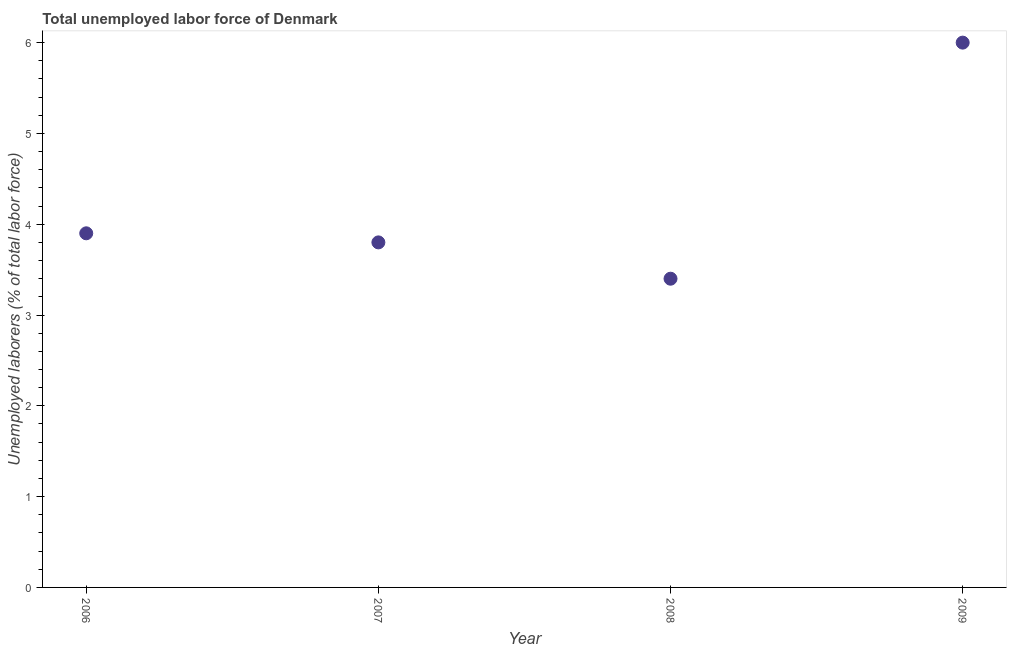What is the total unemployed labour force in 2007?
Provide a succinct answer. 3.8. Across all years, what is the minimum total unemployed labour force?
Provide a short and direct response. 3.4. In which year was the total unemployed labour force minimum?
Provide a short and direct response. 2008. What is the sum of the total unemployed labour force?
Your answer should be compact. 17.1. What is the difference between the total unemployed labour force in 2007 and 2009?
Give a very brief answer. -2.2. What is the average total unemployed labour force per year?
Offer a terse response. 4.28. What is the median total unemployed labour force?
Offer a very short reply. 3.85. In how many years, is the total unemployed labour force greater than 2.2 %?
Make the answer very short. 4. What is the ratio of the total unemployed labour force in 2007 to that in 2008?
Keep it short and to the point. 1.12. Is the difference between the total unemployed labour force in 2008 and 2009 greater than the difference between any two years?
Your answer should be very brief. Yes. What is the difference between the highest and the second highest total unemployed labour force?
Your answer should be very brief. 2.1. Is the sum of the total unemployed labour force in 2007 and 2008 greater than the maximum total unemployed labour force across all years?
Provide a short and direct response. Yes. What is the difference between the highest and the lowest total unemployed labour force?
Your response must be concise. 2.6. In how many years, is the total unemployed labour force greater than the average total unemployed labour force taken over all years?
Give a very brief answer. 1. How many dotlines are there?
Your response must be concise. 1. How many years are there in the graph?
Keep it short and to the point. 4. What is the difference between two consecutive major ticks on the Y-axis?
Provide a short and direct response. 1. Are the values on the major ticks of Y-axis written in scientific E-notation?
Ensure brevity in your answer.  No. Does the graph contain grids?
Make the answer very short. No. What is the title of the graph?
Keep it short and to the point. Total unemployed labor force of Denmark. What is the label or title of the Y-axis?
Keep it short and to the point. Unemployed laborers (% of total labor force). What is the Unemployed laborers (% of total labor force) in 2006?
Your answer should be compact. 3.9. What is the Unemployed laborers (% of total labor force) in 2007?
Your answer should be compact. 3.8. What is the Unemployed laborers (% of total labor force) in 2008?
Your response must be concise. 3.4. What is the Unemployed laborers (% of total labor force) in 2009?
Keep it short and to the point. 6. What is the difference between the Unemployed laborers (% of total labor force) in 2006 and 2007?
Give a very brief answer. 0.1. What is the difference between the Unemployed laborers (% of total labor force) in 2006 and 2008?
Keep it short and to the point. 0.5. What is the difference between the Unemployed laborers (% of total labor force) in 2006 and 2009?
Offer a very short reply. -2.1. What is the difference between the Unemployed laborers (% of total labor force) in 2007 and 2008?
Give a very brief answer. 0.4. What is the ratio of the Unemployed laborers (% of total labor force) in 2006 to that in 2007?
Your answer should be very brief. 1.03. What is the ratio of the Unemployed laborers (% of total labor force) in 2006 to that in 2008?
Your answer should be compact. 1.15. What is the ratio of the Unemployed laborers (% of total labor force) in 2006 to that in 2009?
Provide a short and direct response. 0.65. What is the ratio of the Unemployed laborers (% of total labor force) in 2007 to that in 2008?
Your answer should be compact. 1.12. What is the ratio of the Unemployed laborers (% of total labor force) in 2007 to that in 2009?
Make the answer very short. 0.63. What is the ratio of the Unemployed laborers (% of total labor force) in 2008 to that in 2009?
Give a very brief answer. 0.57. 